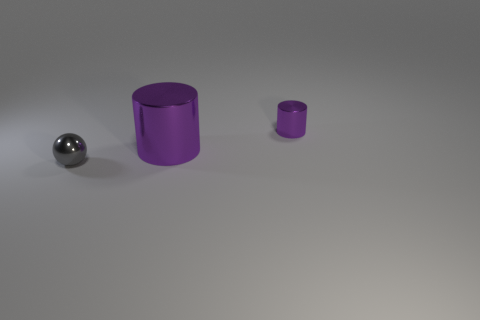What size is the shiny object behind the metallic cylinder that is in front of the small purple thing? The shiny spherical object behind the larger metallic cylinder, which stands in front of the smaller purple cylinder, appears to be relatively small in size, approximately similar in scale to the smaller purple object. 